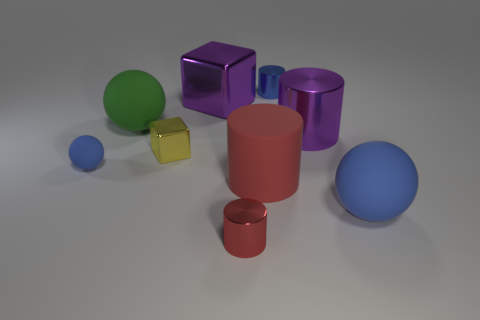Add 1 big green balls. How many objects exist? 10 Subtract all blocks. How many objects are left? 7 Subtract all tiny green cylinders. Subtract all big green rubber objects. How many objects are left? 8 Add 5 purple cubes. How many purple cubes are left? 6 Add 2 big red blocks. How many big red blocks exist? 2 Subtract 0 red cubes. How many objects are left? 9 